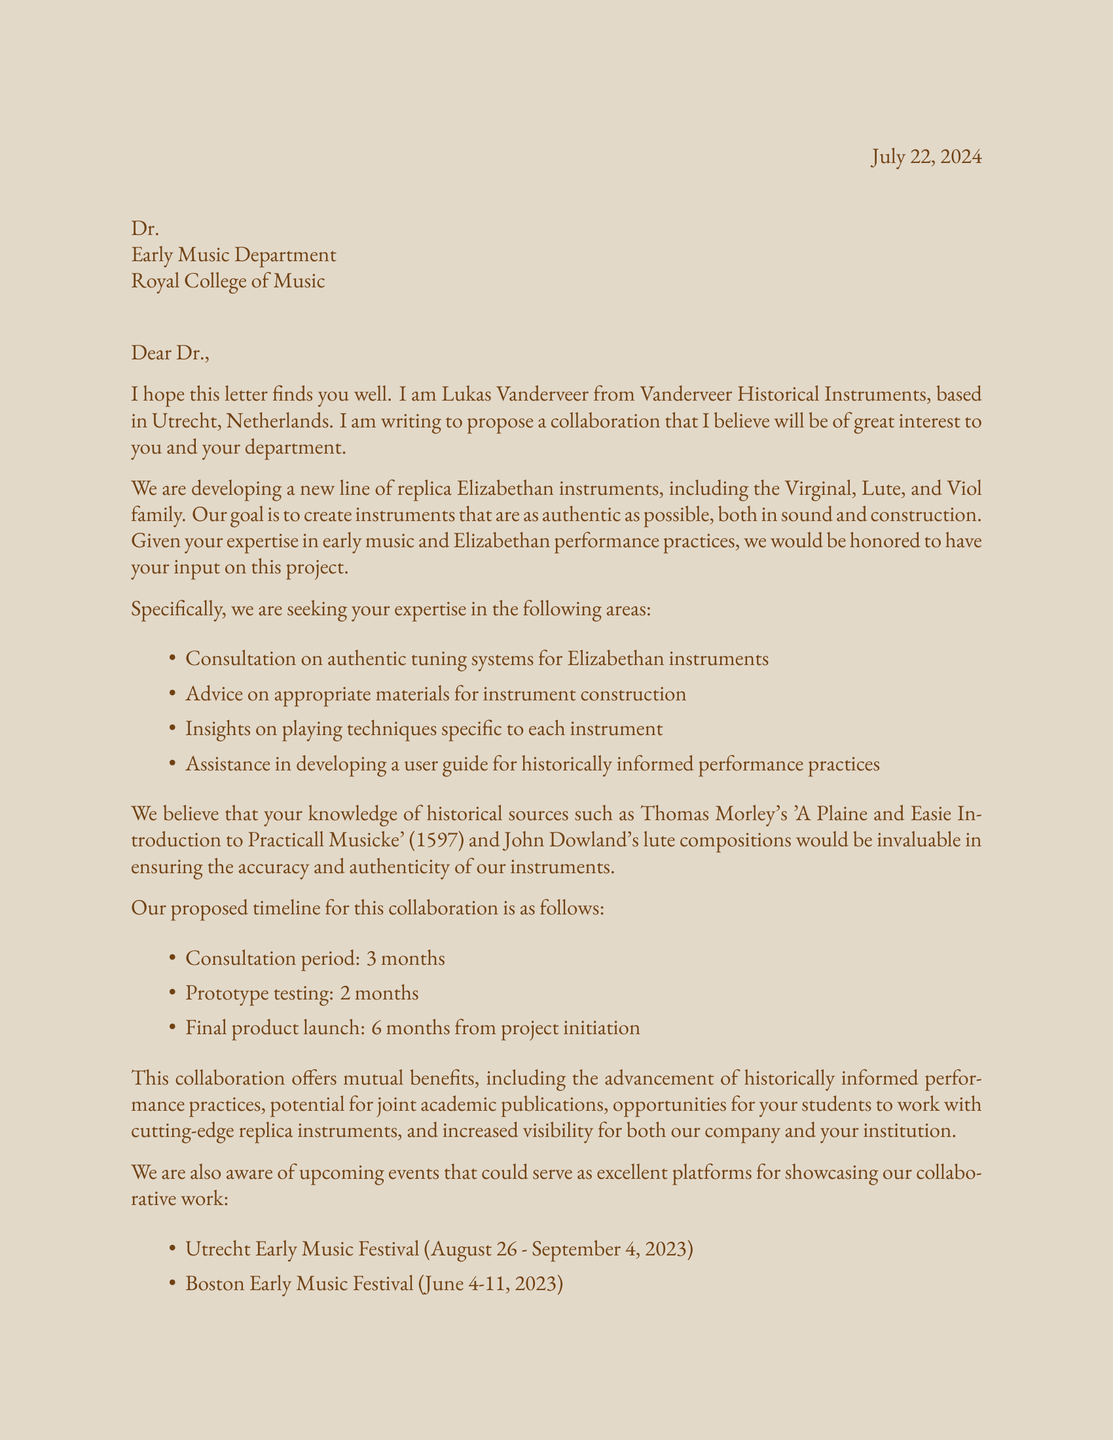What is the sender's name? The sender's name is listed at the beginning of the letter as Lukas Vanderveer.
Answer: Lukas Vanderveer What instruments are being developed? The letter specifies three instruments: the Virginal, Lute, and Viol family.
Answer: Virginal, Lute, Viol What is the consultation period duration? The document mentions a consultation period of 3 months as part of the proposed timeline.
Answer: 3 months Which historical treatise is referenced? The letter references Thomas Morley's 'A Plaine and Easie Introduction to Practicall Musicke' as a historical source.
Answer: Thomas Morley's 'A Plaine and Easie Introduction to Practicall Musicke' What is the total time from project initiation to final product launch? The letter outlines a timeline where the final product launch occurs 6 months from project initiation.
Answer: 6 months What is one mutual benefit of the collaboration? One mutually beneficial outcome mentioned is the advancement of historically informed performance practices.
Answer: Advancement of historically informed performance practices Name one upcoming event mentioned. The letter lists the Utrecht Early Music Festival and the Boston Early Music Festival as upcoming events.
Answer: Utrecht Early Music Festival What type of instruments is the proposed collaboration focused on? The collaboration focuses on replica Elizabethan instruments.
Answer: Replica Elizabethan instruments 